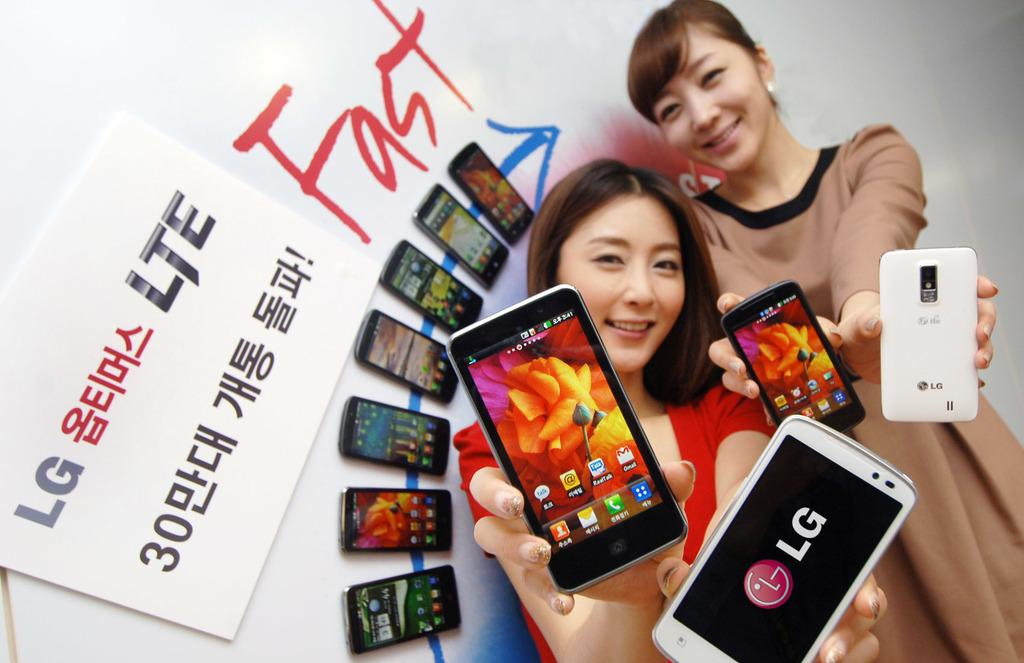Provide a one-sentence caption for the provided image. LG phone being help by two females next to a sign. 